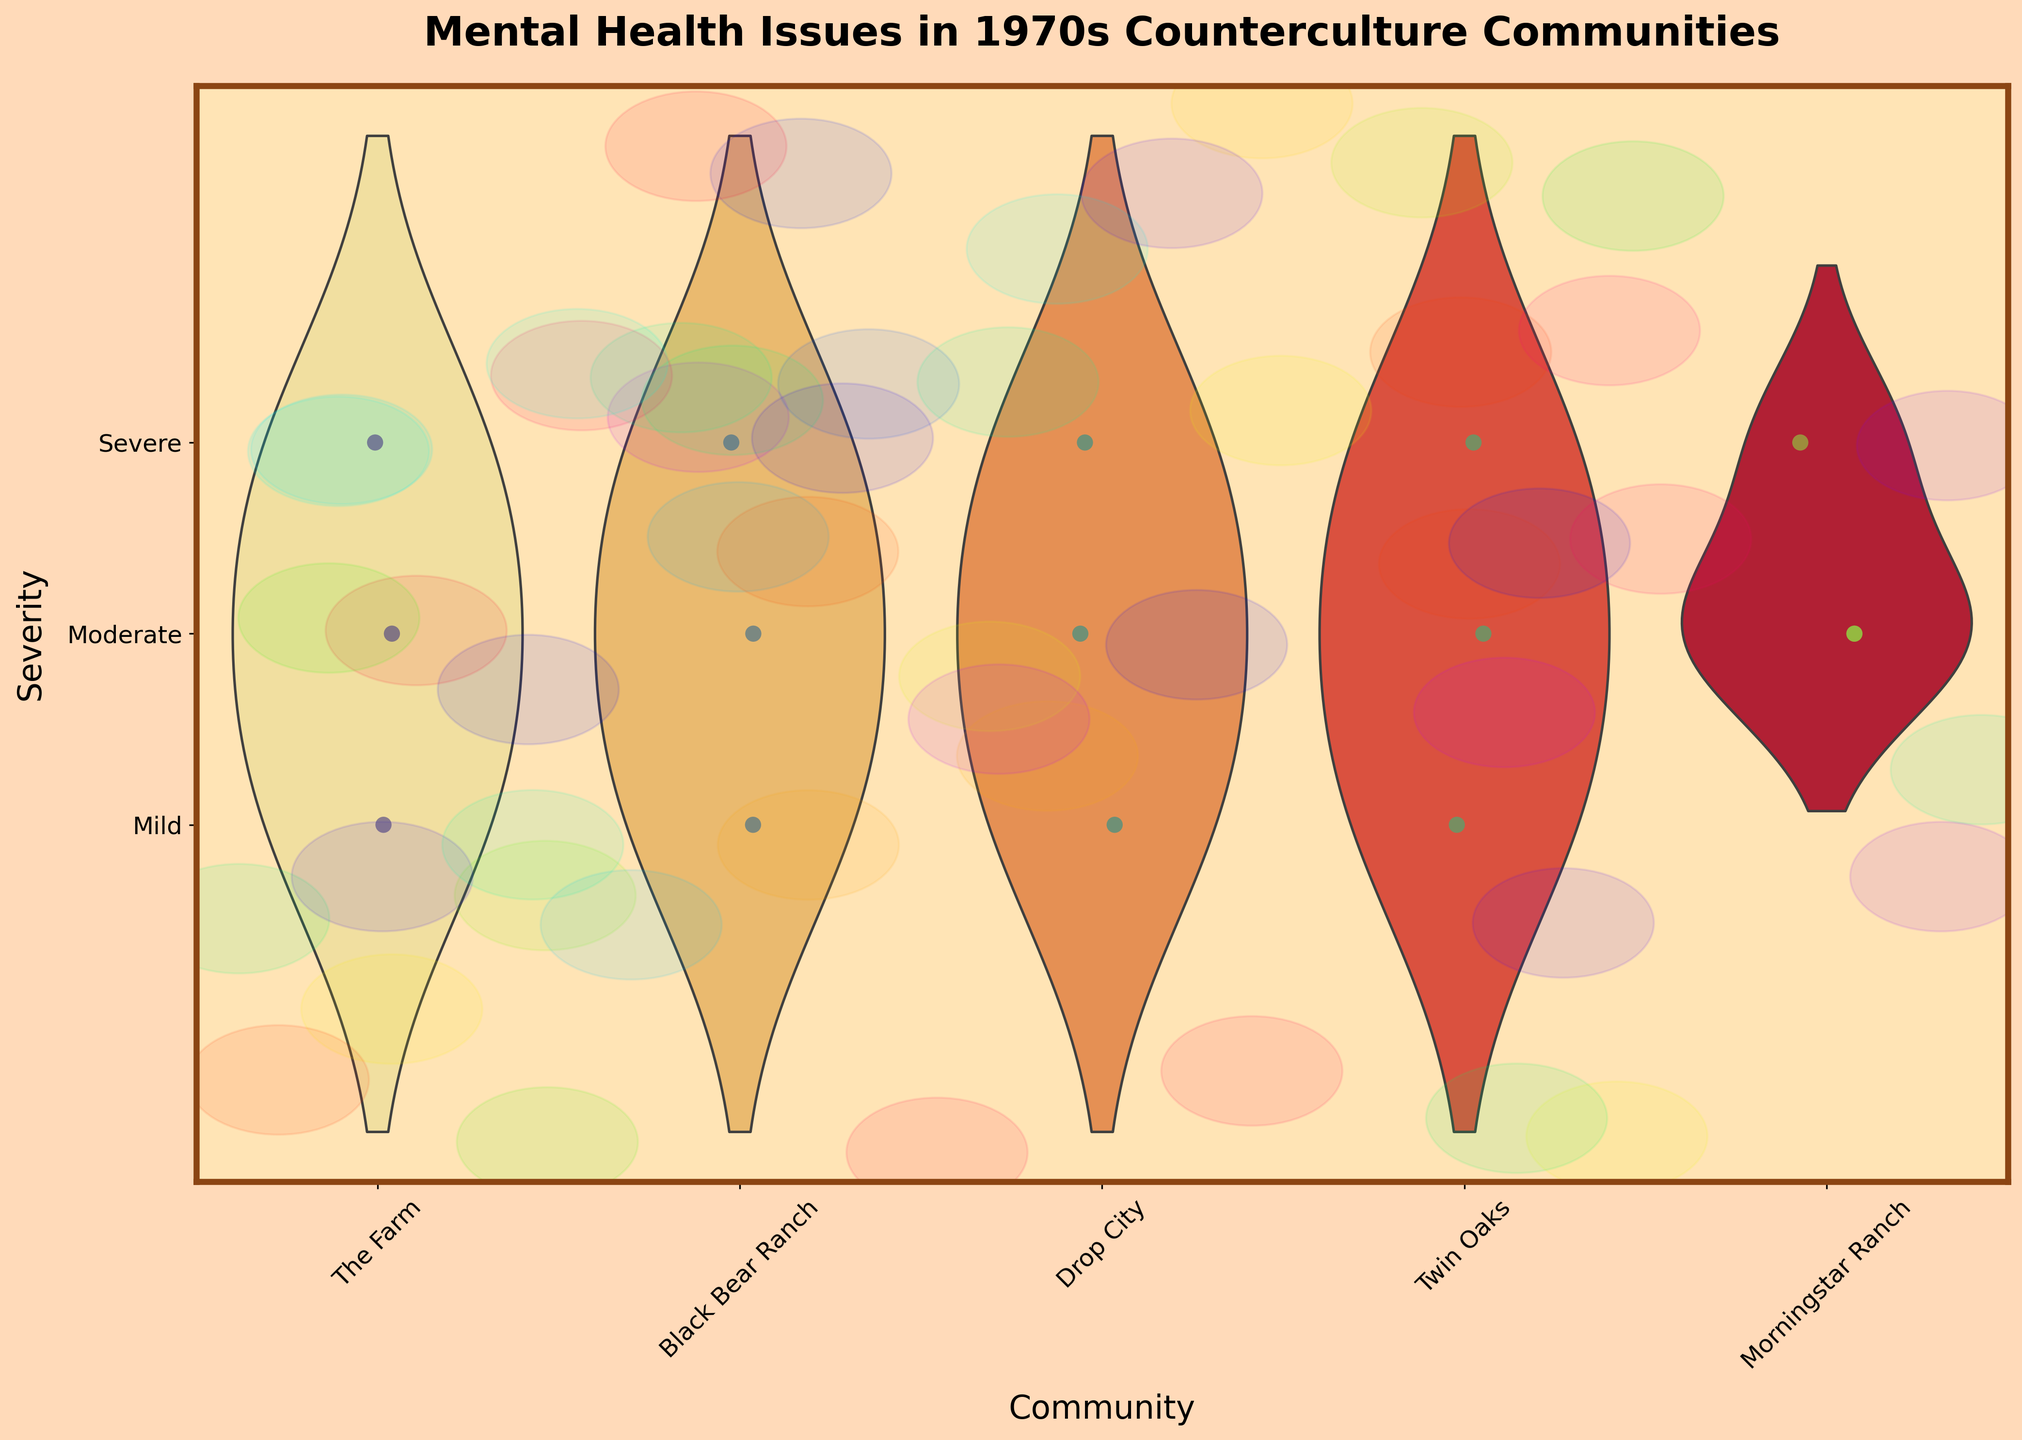what is the title of the chart? The title of the chart is located at the top part of the figure and reads as "Mental Health Issues in 1970s Counterculture Communities."
Answer: Mental Health Issues in 1970s Counterculture Communities What are the severity levels used in this chart? The severity levels are indicated along the y-axis using specific labels. They are "Mild," "Moderate," and "Severe," which correspond to severity levels 1, 2, and 3 respectively.
Answer: Mild, Moderate, Severe Which community appears to have the most severe cases of mental health issues? By observing the jittered points and the violin plot distributions, we see that "The Farm" and "Drop City" show points at the highest severity level (3). However, the exact most severe community might require further counting.
Answer: The Farm, Drop City How does the distribution of mental health issue severities in “Twin Oaks” compare to “The Farm”? In “Twin Oaks,” there seem to be fewer severe cases (level 3) compared to "The Farm." The jittered points and the shapes of the violins indicate that "The Farm" has more concentration towards moderate and severe levels.
Answer: Twin Oaks has fewer severe cases compared to The Farm Which severity level is most common in "Morningstar Ranch?" By observing the density of the violin plot for “Morningstar Ranch,” the level with the widest part of the violin plot indicates the most frequent severity. It appears that the "Moderate" level is the most common.
Answer: Moderate In how many communities is “Moderate” the most frequent severity level? By examining the width of the violin plots at the severity level corresponding to "Moderate" (2), it appears that "Moderate" is the most frequent in "Morningstar Ranch," "Twin Oaks," and potentially "The Farm." So that makes at least three.
Answer: Three communities Compare the spread of mental health severity distributions between “Black Bear Ranch” and “Drop City.” "Black Bear Ranch" shows a more evenly distributed spread across all severity levels, while “Drop City” has a more concentrated spread at the severe level (3), as seen by the wider top of the violin plot.
Answer: Black Bear Ranch is more evenly distributed, Drop City is concentrated at severe Which community has the least data points shown on the plot? By counting the jittered points for each community, “Morningstar Ranch” appears to have fewer data points compared to others.
Answer: Morningstar Ranch 